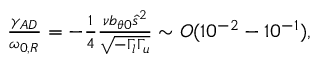<formula> <loc_0><loc_0><loc_500><loc_500>\begin{array} { r } { \frac { \gamma _ { A D } } { \omega _ { 0 , R } } = - \frac { 1 } { 4 } \frac { \nu b _ { \theta 0 } \hat { s } ^ { 2 } } { \sqrt { - \Gamma _ { l } \Gamma _ { u } } } \sim O ( 1 0 ^ { - 2 } - 1 0 ^ { - 1 } ) , } \end{array}</formula> 